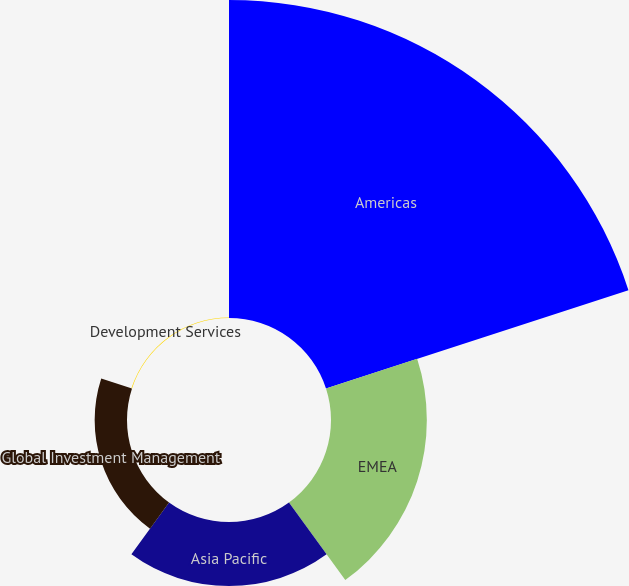<chart> <loc_0><loc_0><loc_500><loc_500><pie_chart><fcel>Americas<fcel>EMEA<fcel>Asia Pacific<fcel>Global Investment Management<fcel>Development Services<nl><fcel>62.25%<fcel>18.76%<fcel>12.54%<fcel>6.33%<fcel>0.12%<nl></chart> 